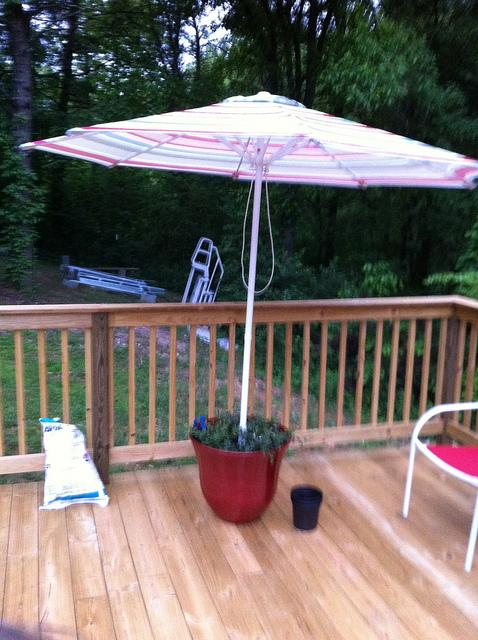What is inside the flower pot? Please explain your reasoning. umbrella. This is holding it upright 